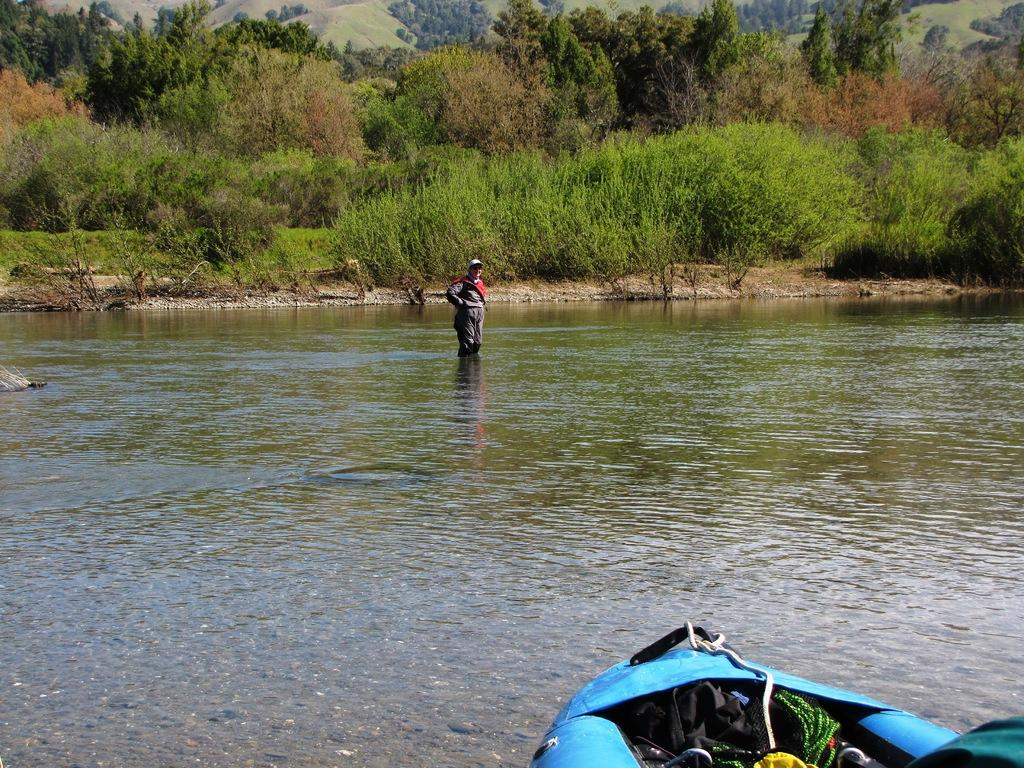What is the main subject of the image? The main subject of the image is a boat with objects in it. Can you describe the person in the image? There is a person standing on the water in the image. What can be seen in the background of the image? There are trees in the background of the image. What type of bread can be seen floating near the person in the image? There is no bread present in the image; the person is standing on the water. 